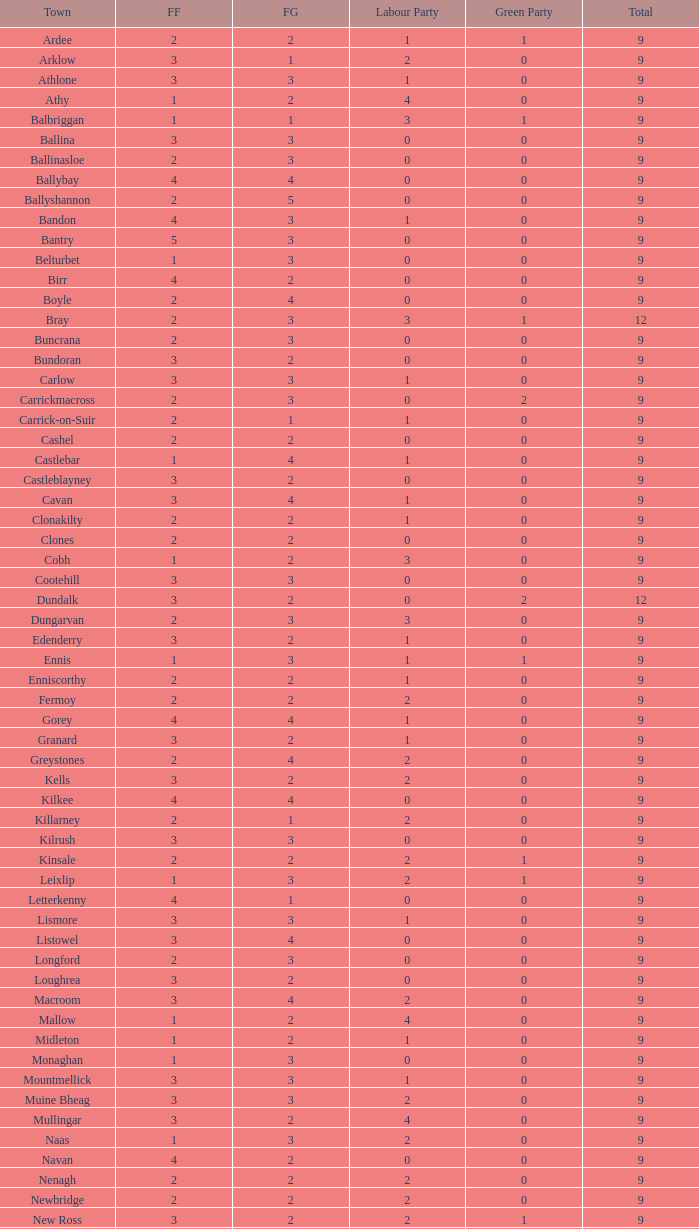How many are in the Labour Party of a Fianna Fail of 3 with a total higher than 9 and more than 2 in the Green Party? None. 